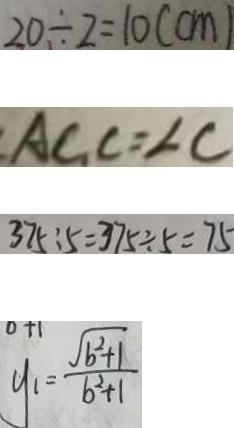<formula> <loc_0><loc_0><loc_500><loc_500>2 0 \div 2 = 1 0 ( c m ) 
 A C _ { 1 } C = \angle C 
 3 7 5 : 5 = 3 7 5 \div 5 = 7 5 
 y _ { 1 } = \frac { \sqrt { b ^ { 2 } + 1 } } { b ^ { 2 } + 1 }</formula> 